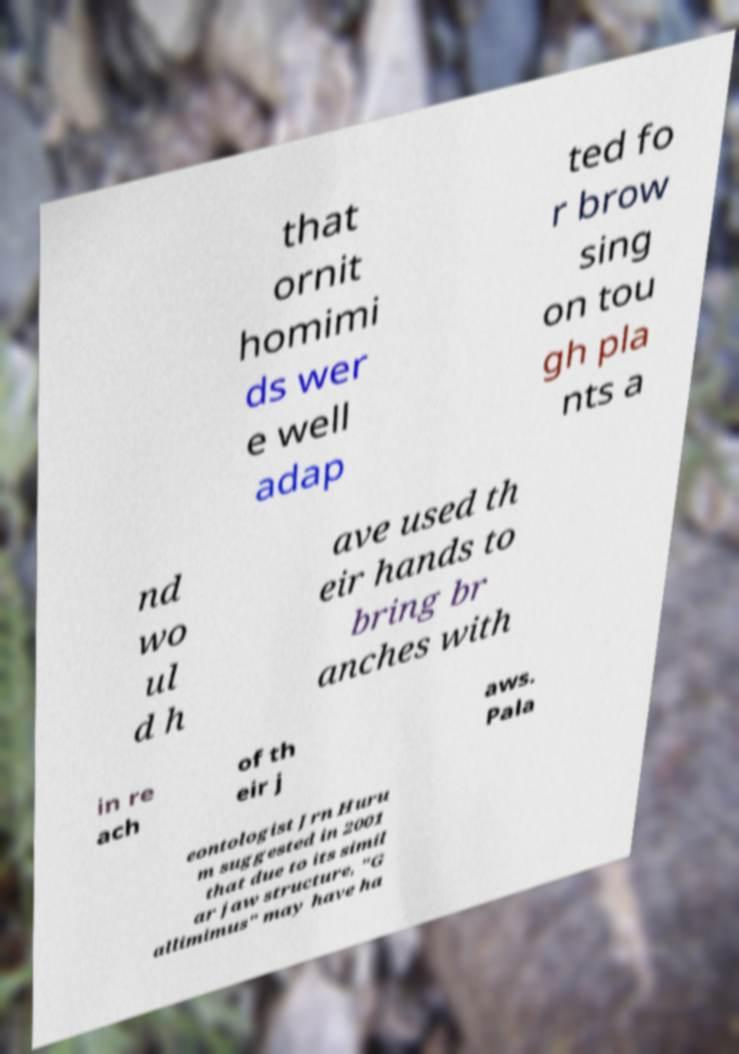There's text embedded in this image that I need extracted. Can you transcribe it verbatim? that ornit homimi ds wer e well adap ted fo r brow sing on tou gh pla nts a nd wo ul d h ave used th eir hands to bring br anches with in re ach of th eir j aws. Pala eontologist Jrn Huru m suggested in 2001 that due to its simil ar jaw structure, "G allimimus" may have ha 